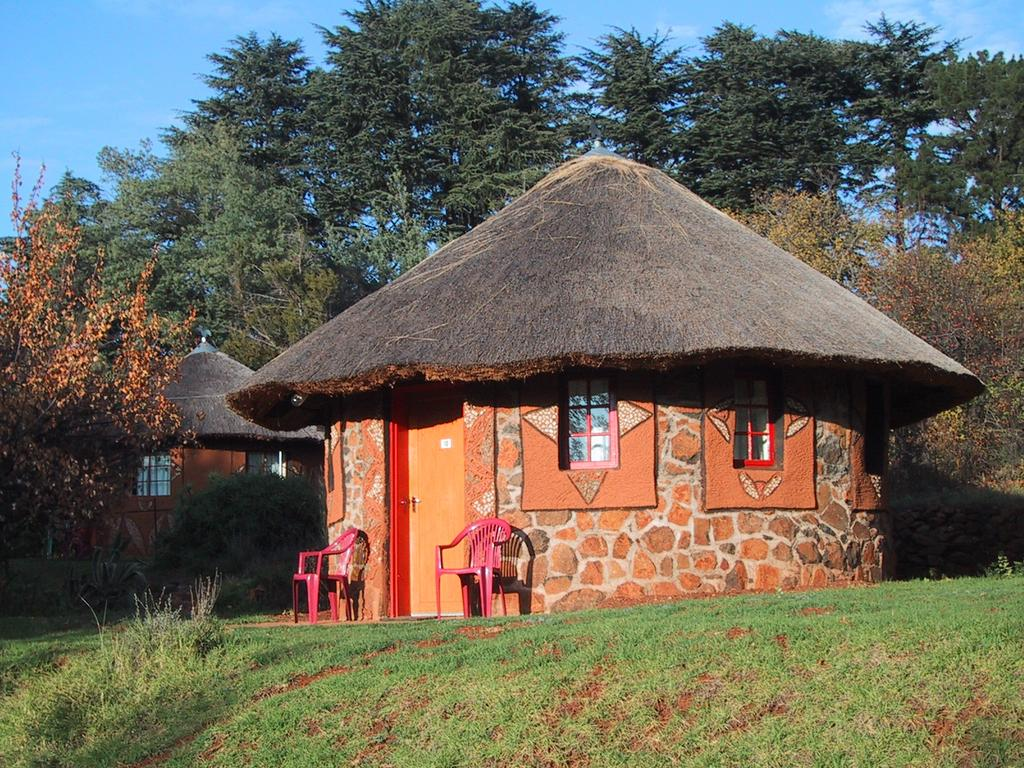What type of structures can be seen in the image? There are huts in the image. What natural elements are present in the image? Trees are present in the image. What type of furniture is visible in the image? Chairs are visible in the image. What architectural features can be seen on the huts? There is a door and windows present in the image. What is visible in the sky at the top of the image? Clouds are visible in the sky at the top of the image. What type of ground covering can be seen at the bottom of the image? The ground is covered with grass at the bottom of the image. What grade is the giraffe in the image? There is no giraffe present in the image. How many beads are on the windowsill in the image? There is no mention of beads in the image, so it is impossible to determine their presence or quantity. 